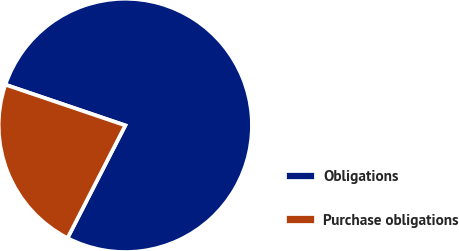Convert chart. <chart><loc_0><loc_0><loc_500><loc_500><pie_chart><fcel>Obligations<fcel>Purchase obligations<nl><fcel>77.33%<fcel>22.67%<nl></chart> 